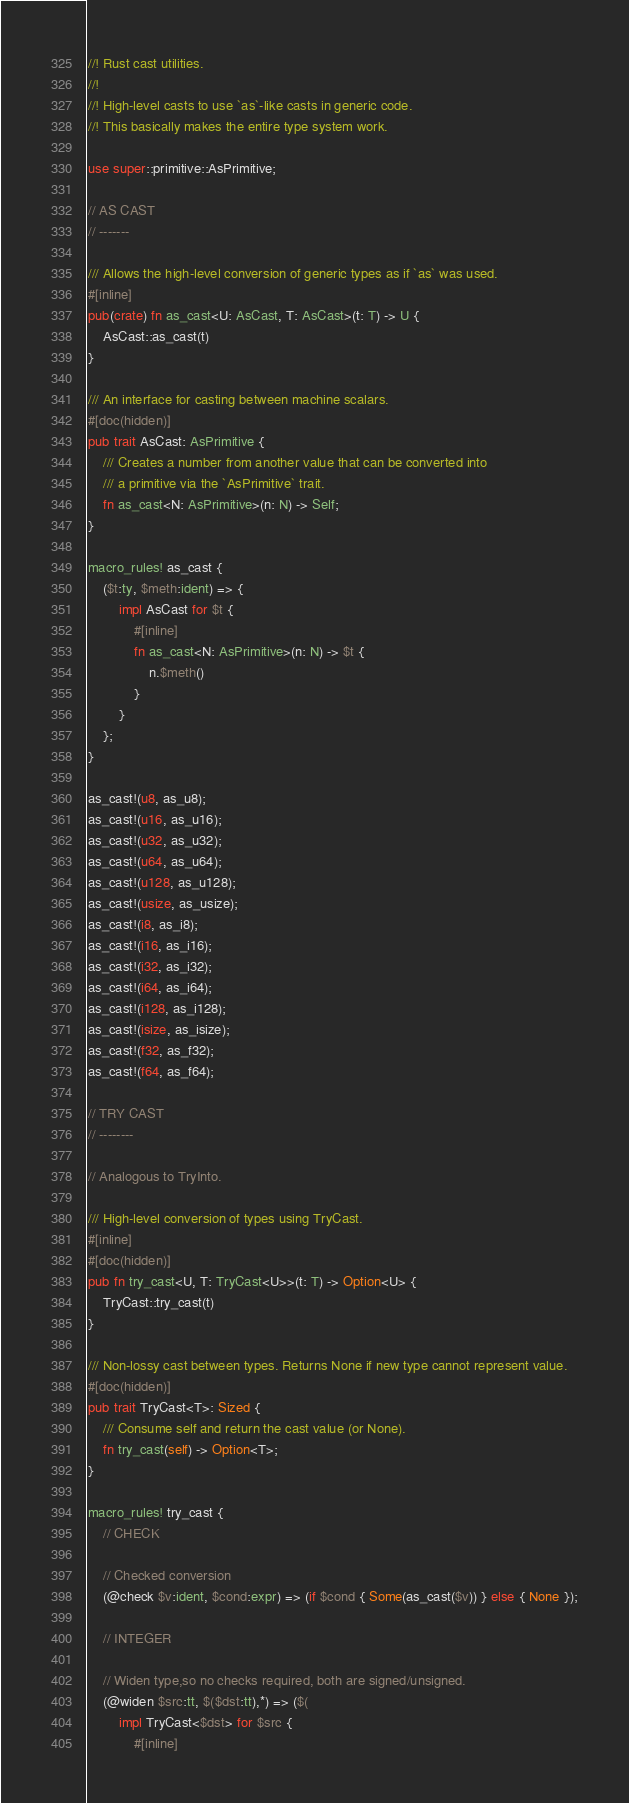<code> <loc_0><loc_0><loc_500><loc_500><_Rust_>//! Rust cast utilities.
//!
//! High-level casts to use `as`-like casts in generic code.
//! This basically makes the entire type system work.

use super::primitive::AsPrimitive;

// AS CAST
// -------

/// Allows the high-level conversion of generic types as if `as` was used.
#[inline]
pub(crate) fn as_cast<U: AsCast, T: AsCast>(t: T) -> U {
    AsCast::as_cast(t)
}

/// An interface for casting between machine scalars.
#[doc(hidden)]
pub trait AsCast: AsPrimitive {
    /// Creates a number from another value that can be converted into
    /// a primitive via the `AsPrimitive` trait.
    fn as_cast<N: AsPrimitive>(n: N) -> Self;
}

macro_rules! as_cast {
    ($t:ty, $meth:ident) => {
        impl AsCast for $t {
            #[inline]
            fn as_cast<N: AsPrimitive>(n: N) -> $t {
                n.$meth()
            }
        }
    };
}

as_cast!(u8, as_u8);
as_cast!(u16, as_u16);
as_cast!(u32, as_u32);
as_cast!(u64, as_u64);
as_cast!(u128, as_u128);
as_cast!(usize, as_usize);
as_cast!(i8, as_i8);
as_cast!(i16, as_i16);
as_cast!(i32, as_i32);
as_cast!(i64, as_i64);
as_cast!(i128, as_i128);
as_cast!(isize, as_isize);
as_cast!(f32, as_f32);
as_cast!(f64, as_f64);

// TRY CAST
// --------

// Analogous to TryInto.

/// High-level conversion of types using TryCast.
#[inline]
#[doc(hidden)]
pub fn try_cast<U, T: TryCast<U>>(t: T) -> Option<U> {
    TryCast::try_cast(t)
}

/// Non-lossy cast between types. Returns None if new type cannot represent value.
#[doc(hidden)]
pub trait TryCast<T>: Sized {
    /// Consume self and return the cast value (or None).
    fn try_cast(self) -> Option<T>;
}

macro_rules! try_cast {
    // CHECK

    // Checked conversion
    (@check $v:ident, $cond:expr) => (if $cond { Some(as_cast($v)) } else { None });

    // INTEGER

    // Widen type,so no checks required, both are signed/unsigned.
    (@widen $src:tt, $($dst:tt),*) => ($(
        impl TryCast<$dst> for $src {
            #[inline]</code> 